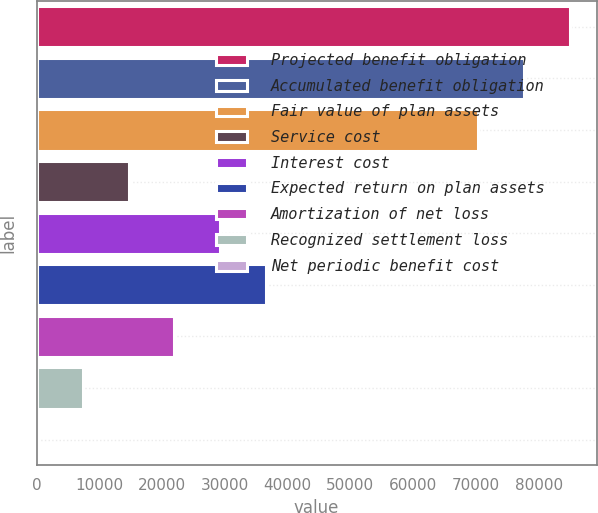<chart> <loc_0><loc_0><loc_500><loc_500><bar_chart><fcel>Projected benefit obligation<fcel>Accumulated benefit obligation<fcel>Fair value of plan assets<fcel>Service cost<fcel>Interest cost<fcel>Expected return on plan assets<fcel>Amortization of net loss<fcel>Recognized settlement loss<fcel>Net periodic benefit cost<nl><fcel>85000.2<fcel>77681.1<fcel>70362<fcel>14653.2<fcel>29291.4<fcel>36610.5<fcel>21972.3<fcel>7334.1<fcel>15<nl></chart> 